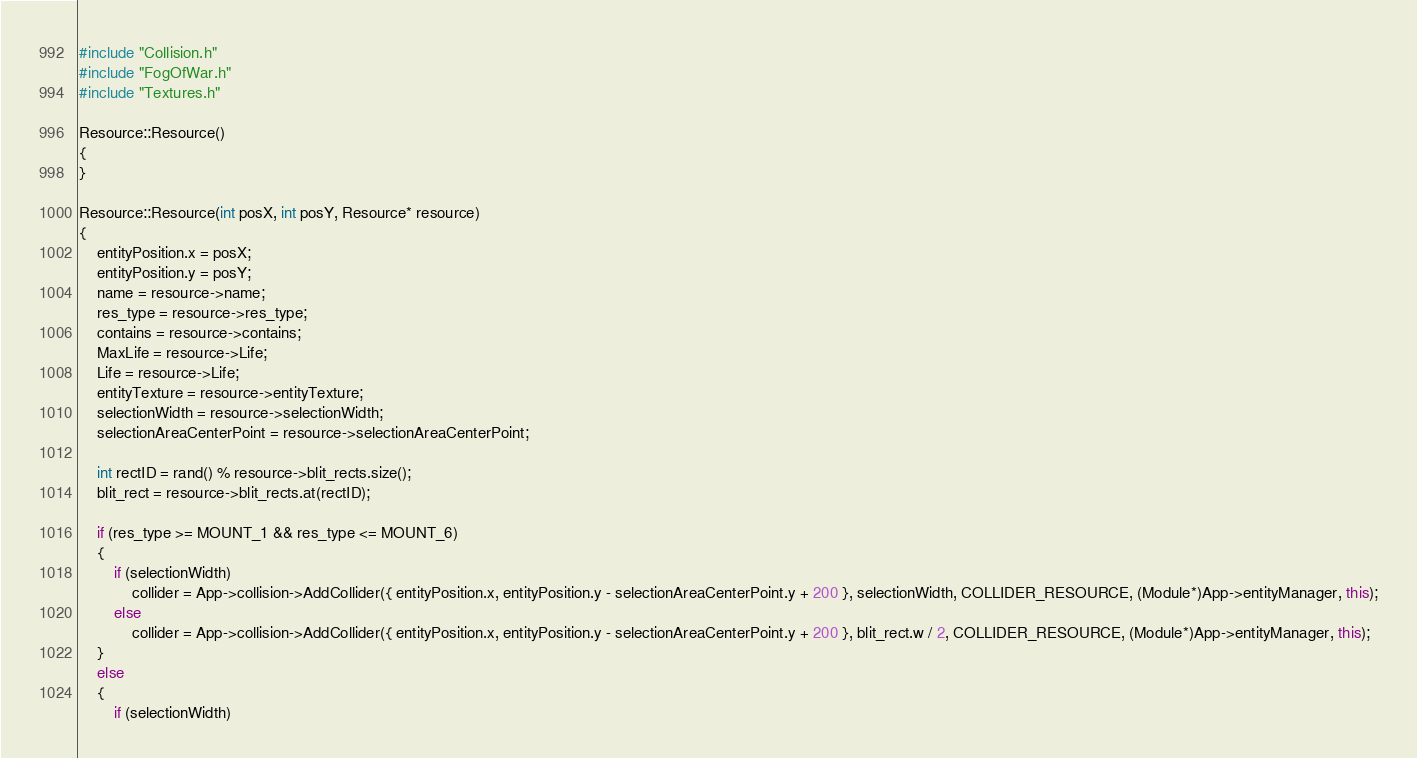<code> <loc_0><loc_0><loc_500><loc_500><_C++_>#include "Collision.h"
#include "FogOfWar.h"
#include "Textures.h"

Resource::Resource()
{
}

Resource::Resource(int posX, int posY, Resource* resource)
{
	entityPosition.x = posX;
	entityPosition.y = posY;
	name = resource->name;
	res_type = resource->res_type;
	contains = resource->contains;
	MaxLife = resource->Life;
	Life = resource->Life;
	entityTexture = resource->entityTexture;
	selectionWidth = resource->selectionWidth;
	selectionAreaCenterPoint = resource->selectionAreaCenterPoint;
	
	int rectID = rand() % resource->blit_rects.size();
	blit_rect = resource->blit_rects.at(rectID);

	if (res_type >= MOUNT_1 && res_type <= MOUNT_6)
	{
		if (selectionWidth)
			collider = App->collision->AddCollider({ entityPosition.x, entityPosition.y - selectionAreaCenterPoint.y + 200 }, selectionWidth, COLLIDER_RESOURCE, (Module*)App->entityManager, this);
		else
			collider = App->collision->AddCollider({ entityPosition.x, entityPosition.y - selectionAreaCenterPoint.y + 200 }, blit_rect.w / 2, COLLIDER_RESOURCE, (Module*)App->entityManager, this);
	}
	else
	{
		if (selectionWidth)</code> 